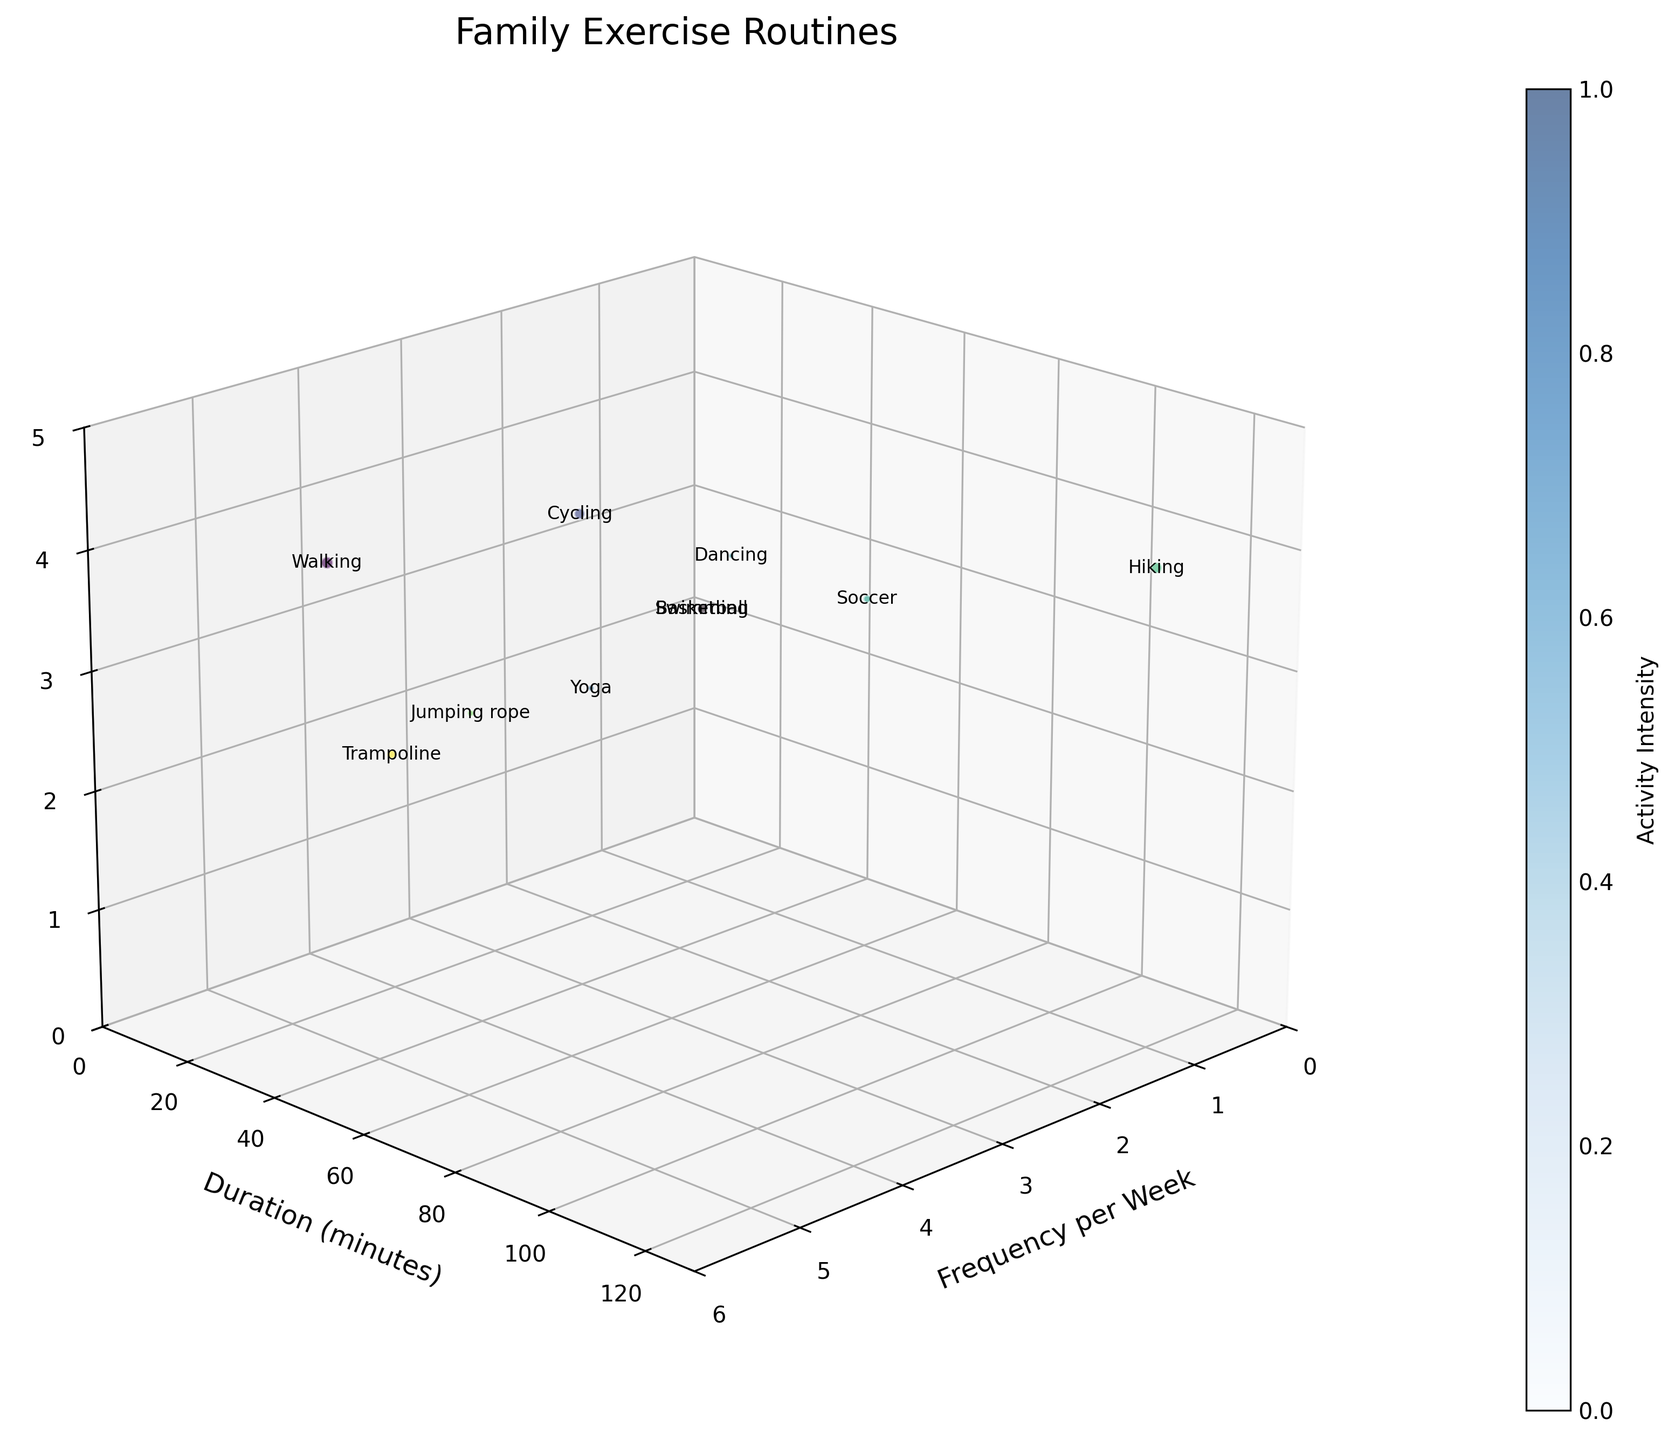What is the title of the chart? The title of the chart is always located at the top and provides the main idea behind the visualization. Observing the top of the figure, we can see the title "Family Exercise Routines".
Answer: Family Exercise Routines What are the labels for the x, y, and z axes? The axis labels describe what each axis represents. By looking at the chart, we can see that the x-axis is labeled "Frequency per Week", the y-axis is labeled "Duration (minutes)", and the z-axis is labeled "Family Members Involved".
Answer: Frequency per Week, Duration (minutes), Family Members Involved How many family members are involved in hiking? Find the bubble labeled "Hiking" on the chart and observe its position on the z-axis, which represents the number of family members involved. The "Hiking" bubble is placed at the z-coordinate of 4.
Answer: 4 Which activity has the highest duration? To identify the activity with the highest duration, we observe the y-axis and find the bubble positioned at the maximum value. The "Hiking" bubble is positioned at 120 minutes, which is the highest duration.
Answer: Hiking Which activities are performed by 3 family members and have a frequency of less than 3 per week? Locate the bubbles on the chart where the z-axis value is 3 and the x-axis value is less than 3. The activities that fit these criteria are "Swimming," "Dancing," and "Soccer."
Answer: Swimming, Dancing, Soccer What is the total frequency per week for all activities combined? Sum the x-axis values (Frequency per Week) for all activities: 5 + 2 + 3 + 2 + 1 + 1 + 1 + 3 + 2 + 4 = 24.
Answer: 24 Which activity involves the least number of family members and what is its duration? Locate the bubbles with the lowest value on the z-axis. "Jumping rope" and "Yoga" both involve 2 family members. The duration for "Jumping rope" is 15 minutes, and the duration for "Yoga" is 20 minutes. Between these, "Jumping rope" has the lowest duration.
Answer: Jumping rope, 15 minutes Are there any activities that last exactly 45 minutes? If so, which ones and how frequently are they performed? Observe the y-axis value of 45 minutes and find the corresponding bubbles. "Swimming" and "Basketball" both last exactly 45 minutes. "Swimming" is performed 2 times a week and "Basketball" is performed 2 times a week.
Answer: Swimming: 2 times, Basketball: 2 times Which activities are done for the same frequency per week but different durations, and what are those durations? Identify bubbles with the same x-axis values but different y-axis values. "Swimming" and "Basketball" are both done 2 times per week, with durations of 45 minutes each. "Yoga" and "Trampoline" are both done 2 times per week with durations of 20 minutes each.
Answer: Swimming: 45 min, Basketball: 45 min; Yoga: 20 min, Trampoline: 20 min What is the size of the bubble for cycling, and how is it calculated? Bubble size is calculated as (Frequency per Week * Duration_minutes)/5. For "Cycling": Frequency per Week = 3, Duration_minutes = 40, so the size is (3*40)/5 = 24.
Answer: 24 